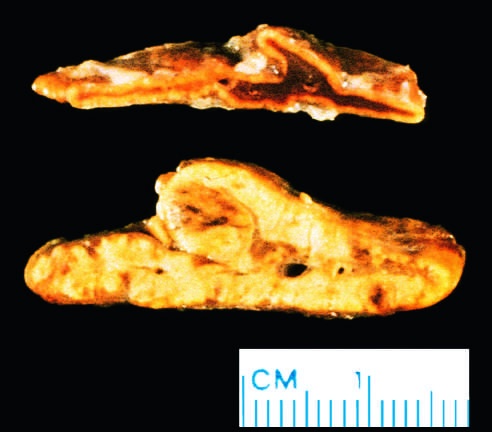what is diffuse hyperplasia of the adrenal gland contrasted with?
Answer the question using a single word or phrase. A normal adrenal gland 